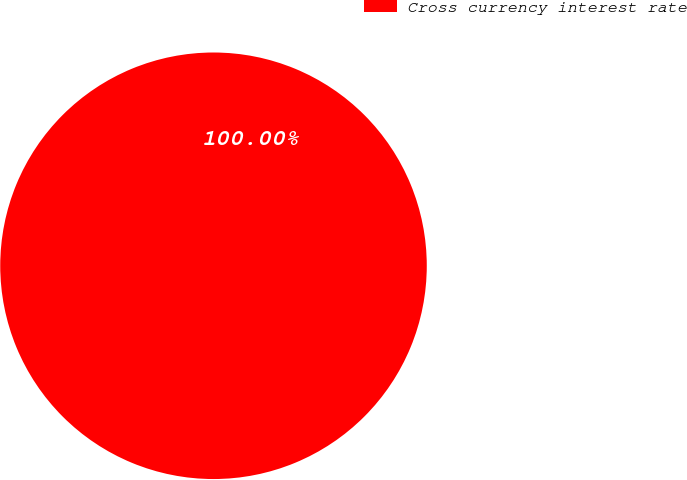<chart> <loc_0><loc_0><loc_500><loc_500><pie_chart><fcel>Cross currency interest rate<nl><fcel>100.0%<nl></chart> 